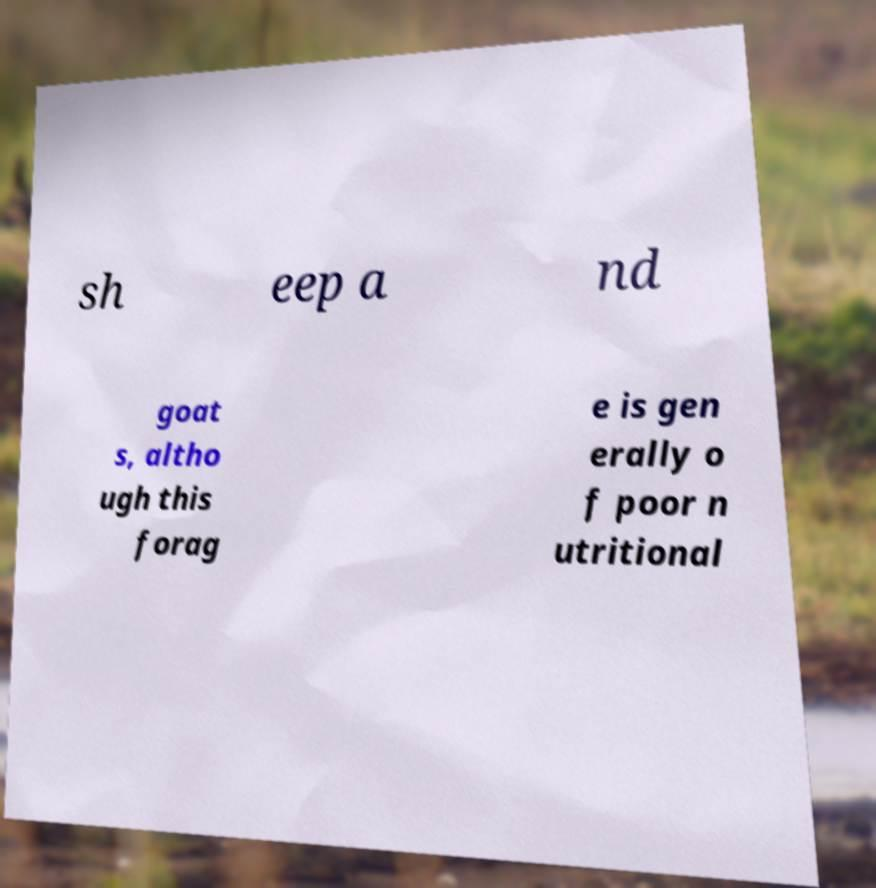Could you assist in decoding the text presented in this image and type it out clearly? sh eep a nd goat s, altho ugh this forag e is gen erally o f poor n utritional 